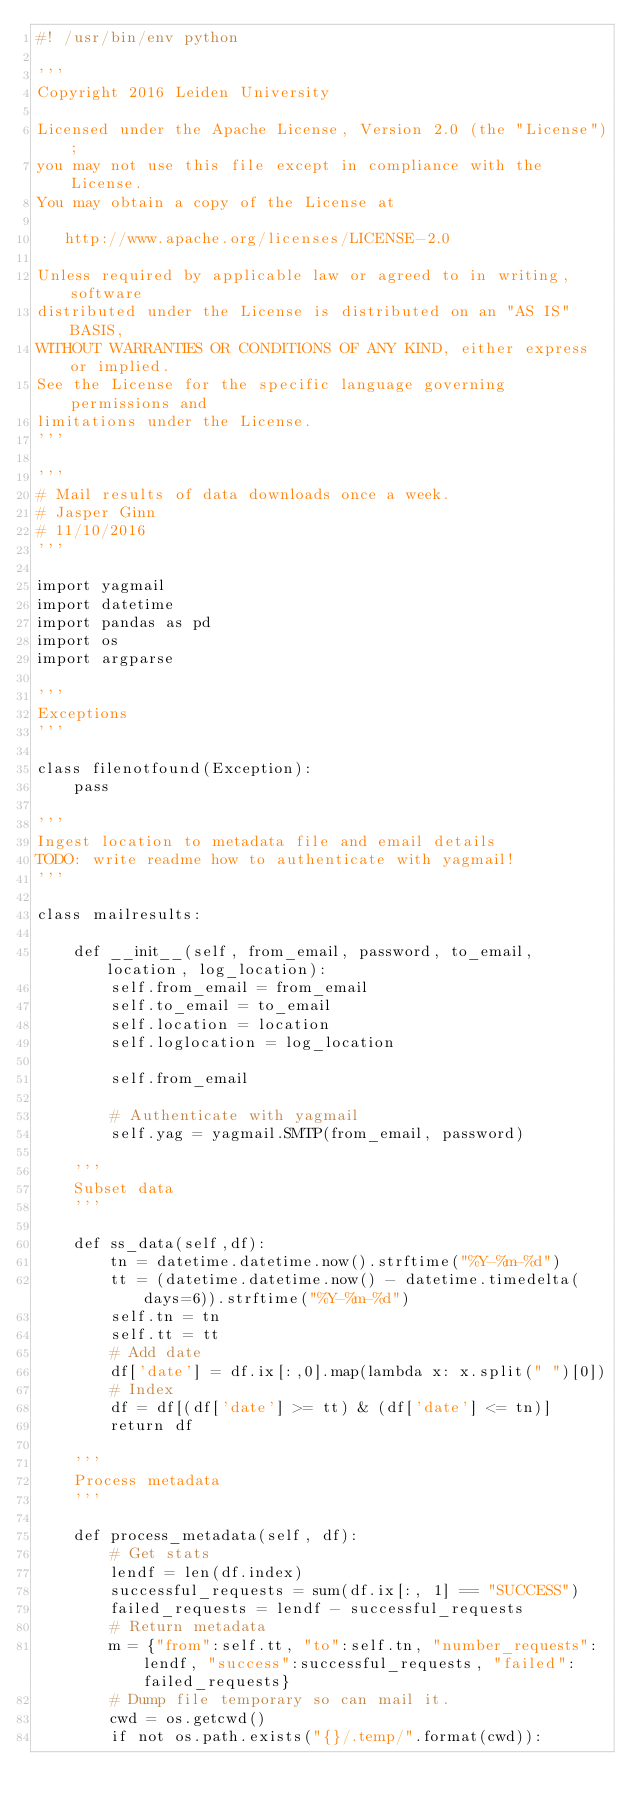Convert code to text. <code><loc_0><loc_0><loc_500><loc_500><_Python_>#! /usr/bin/env python

'''
Copyright 2016 Leiden University

Licensed under the Apache License, Version 2.0 (the "License");
you may not use this file except in compliance with the License.
You may obtain a copy of the License at

   http://www.apache.org/licenses/LICENSE-2.0

Unless required by applicable law or agreed to in writing, software
distributed under the License is distributed on an "AS IS" BASIS,
WITHOUT WARRANTIES OR CONDITIONS OF ANY KIND, either express or implied.
See the License for the specific language governing permissions and
limitations under the License.
'''

'''
# Mail results of data downloads once a week.
# Jasper Ginn
# 11/10/2016
'''

import yagmail
import datetime
import pandas as pd
import os
import argparse

'''
Exceptions
'''

class filenotfound(Exception):
    pass

'''
Ingest location to metadata file and email details
TODO: write readme how to authenticate with yagmail!
'''

class mailresults:

    def __init__(self, from_email, password, to_email, location, log_location):
        self.from_email = from_email
        self.to_email = to_email
        self.location = location
        self.loglocation = log_location

        self.from_email

        # Authenticate with yagmail
        self.yag = yagmail.SMTP(from_email, password)

    '''
    Subset data
    '''

    def ss_data(self,df):
        tn = datetime.datetime.now().strftime("%Y-%m-%d")
        tt = (datetime.datetime.now() - datetime.timedelta(days=6)).strftime("%Y-%m-%d")
        self.tn = tn
        self.tt = tt
        # Add date
        df['date'] = df.ix[:,0].map(lambda x: x.split(" ")[0])
        # Index
        df = df[(df['date'] >= tt) & (df['date'] <= tn)]
        return df

    '''
    Process metadata
    '''

    def process_metadata(self, df):
        # Get stats
        lendf = len(df.index)
        successful_requests = sum(df.ix[:, 1] == "SUCCESS")
        failed_requests = lendf - successful_requests
        # Return metadata
        m = {"from":self.tt, "to":self.tn, "number_requests":lendf, "success":successful_requests, "failed":failed_requests}
        # Dump file temporary so can mail it.
        cwd = os.getcwd()
        if not os.path.exists("{}/.temp/".format(cwd)):</code> 